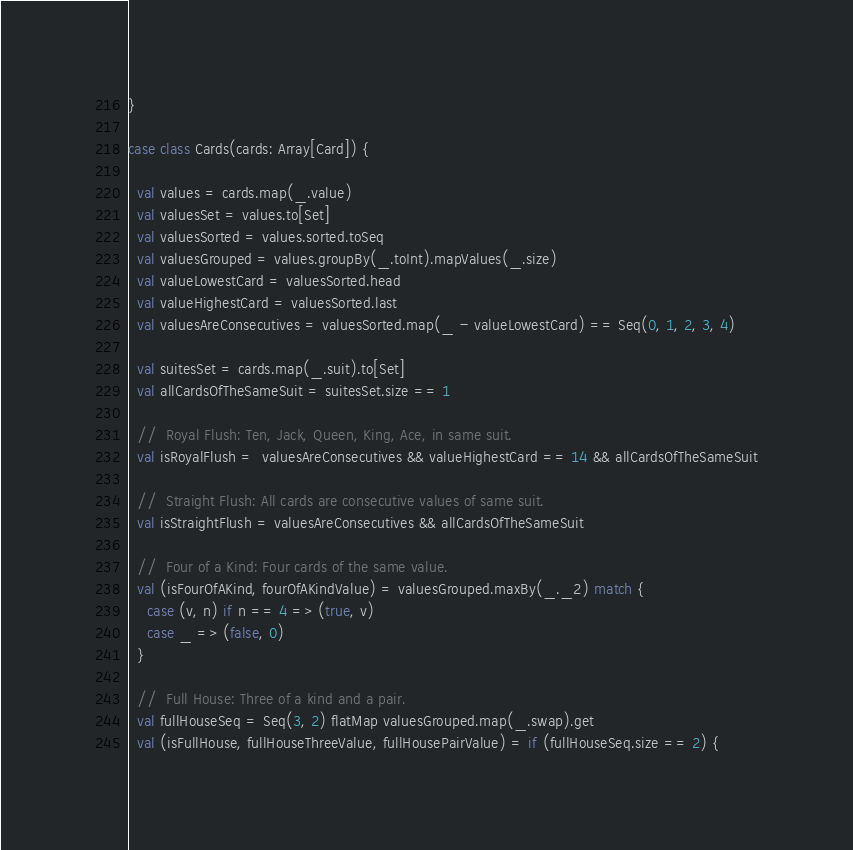Convert code to text. <code><loc_0><loc_0><loc_500><loc_500><_Scala_>}

case class Cards(cards: Array[Card]) {

  val values = cards.map(_.value)
  val valuesSet = values.to[Set]
  val valuesSorted = values.sorted.toSeq
  val valuesGrouped = values.groupBy(_.toInt).mapValues(_.size)
  val valueLowestCard = valuesSorted.head
  val valueHighestCard = valuesSorted.last
  val valuesAreConsecutives = valuesSorted.map(_ - valueLowestCard) == Seq(0, 1, 2, 3, 4)

  val suitesSet = cards.map(_.suit).to[Set]
  val allCardsOfTheSameSuit = suitesSet.size == 1

  //  Royal Flush: Ten, Jack, Queen, King, Ace, in same suit.
  val isRoyalFlush =  valuesAreConsecutives && valueHighestCard == 14 && allCardsOfTheSameSuit

  //  Straight Flush: All cards are consecutive values of same suit.
  val isStraightFlush = valuesAreConsecutives && allCardsOfTheSameSuit

  //  Four of a Kind: Four cards of the same value.
  val (isFourOfAKind, fourOfAKindValue) = valuesGrouped.maxBy(_._2) match {
    case (v, n) if n == 4 => (true, v)
    case _ => (false, 0)
  }

  //  Full House: Three of a kind and a pair.
  val fullHouseSeq = Seq(3, 2) flatMap valuesGrouped.map(_.swap).get
  val (isFullHouse, fullHouseThreeValue, fullHousePairValue) = if (fullHouseSeq.size == 2) {</code> 